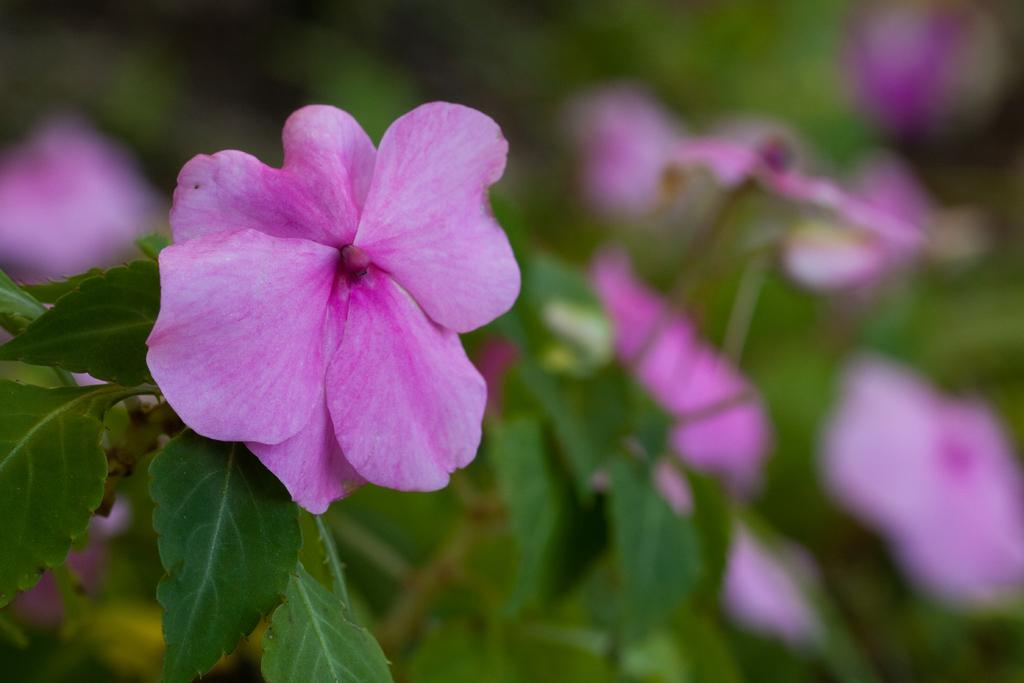What type of living organisms can be seen in the image? Plants can be seen in the image. What specific feature of the plants is visible in the image? The plants have flowers. What route does the father take to reach the plants in the image? There is no father or route present in the image; it only features plants with flowers. 